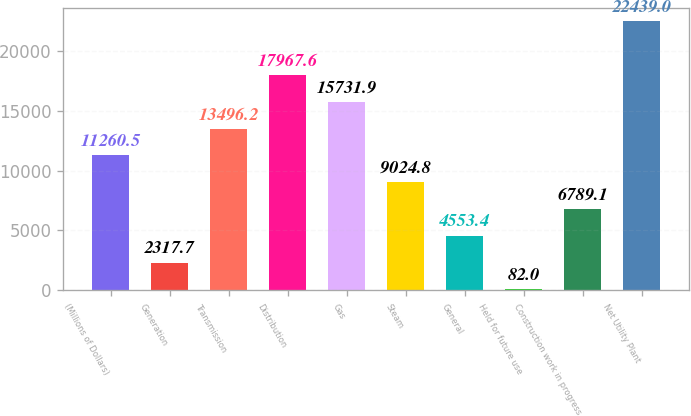<chart> <loc_0><loc_0><loc_500><loc_500><bar_chart><fcel>(Millions of Dollars)<fcel>Generation<fcel>Transmission<fcel>Distribution<fcel>Gas<fcel>Steam<fcel>General<fcel>Held for future use<fcel>Construction work in progress<fcel>Net Utility Plant<nl><fcel>11260.5<fcel>2317.7<fcel>13496.2<fcel>17967.6<fcel>15731.9<fcel>9024.8<fcel>4553.4<fcel>82<fcel>6789.1<fcel>22439<nl></chart> 